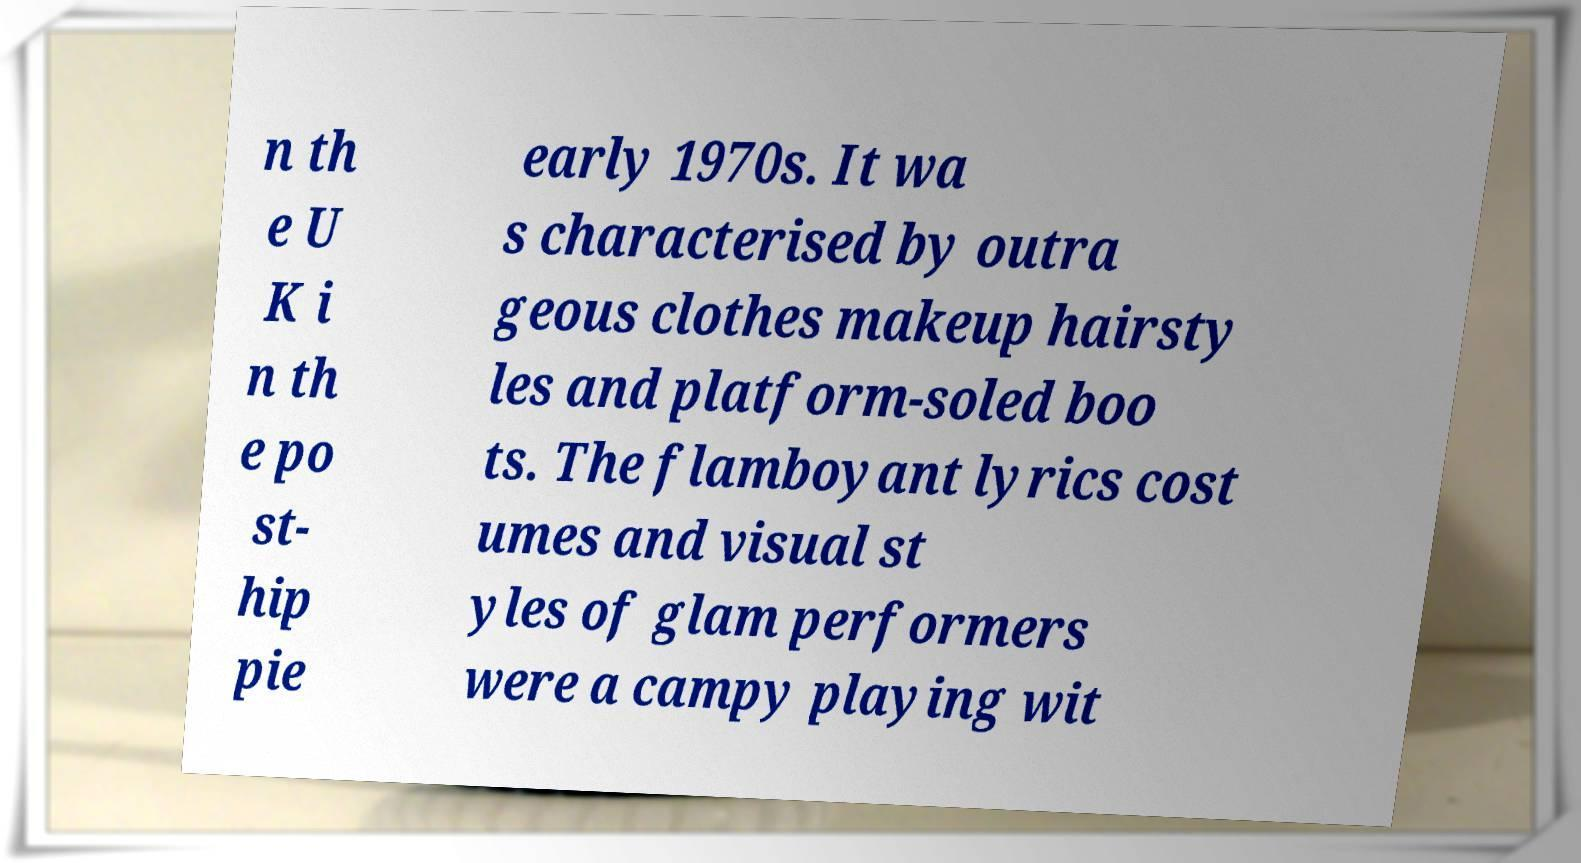Could you extract and type out the text from this image? n th e U K i n th e po st- hip pie early 1970s. It wa s characterised by outra geous clothes makeup hairsty les and platform-soled boo ts. The flamboyant lyrics cost umes and visual st yles of glam performers were a campy playing wit 